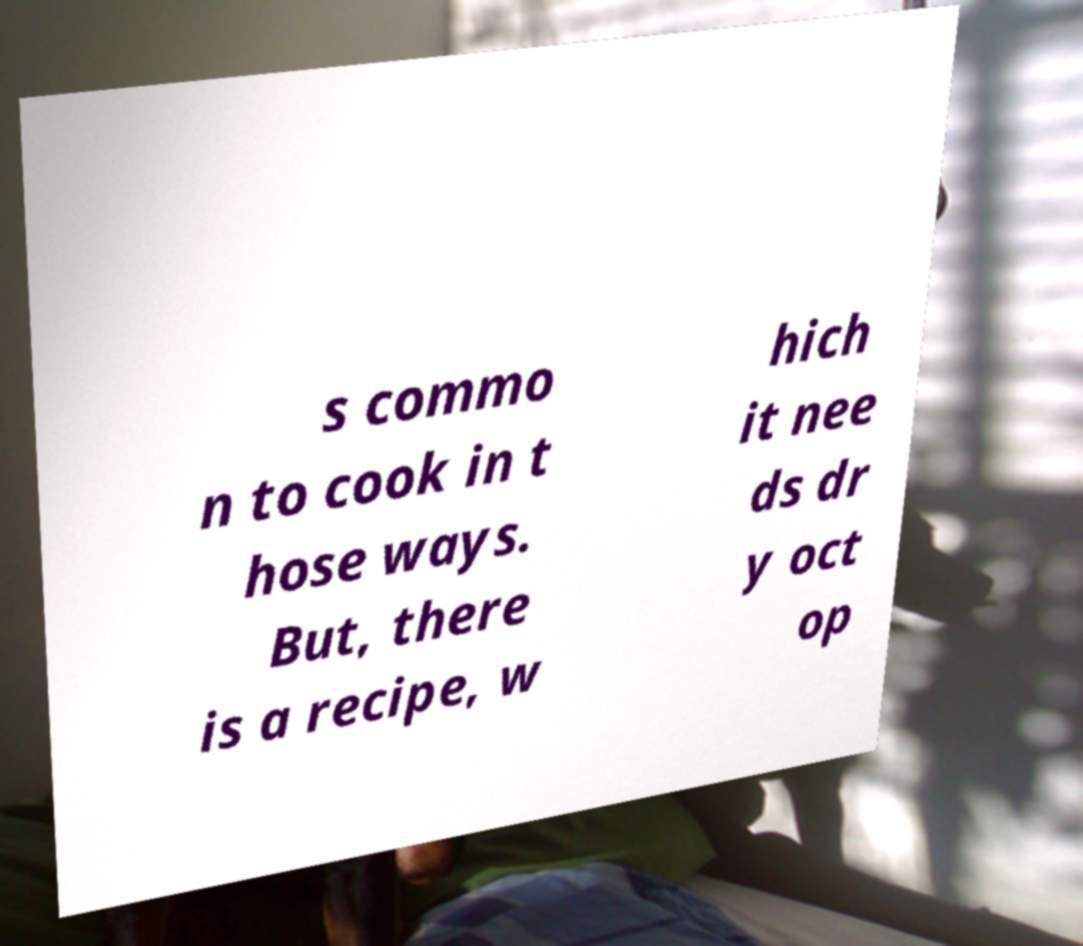Can you read and provide the text displayed in the image?This photo seems to have some interesting text. Can you extract and type it out for me? s commo n to cook in t hose ways. But, there is a recipe, w hich it nee ds dr y oct op 